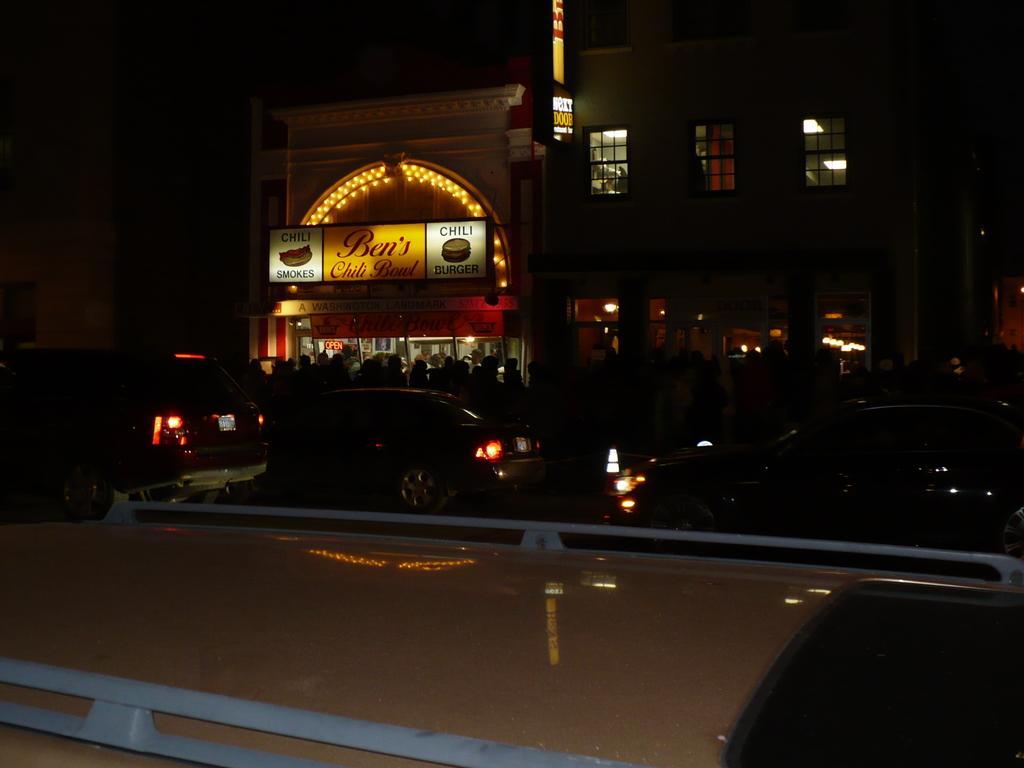Please provide a concise description of this image. In this image I can see few buildings, few boards and few vehicles. I can also see something is written on these boards and I can see this image is in dark. 